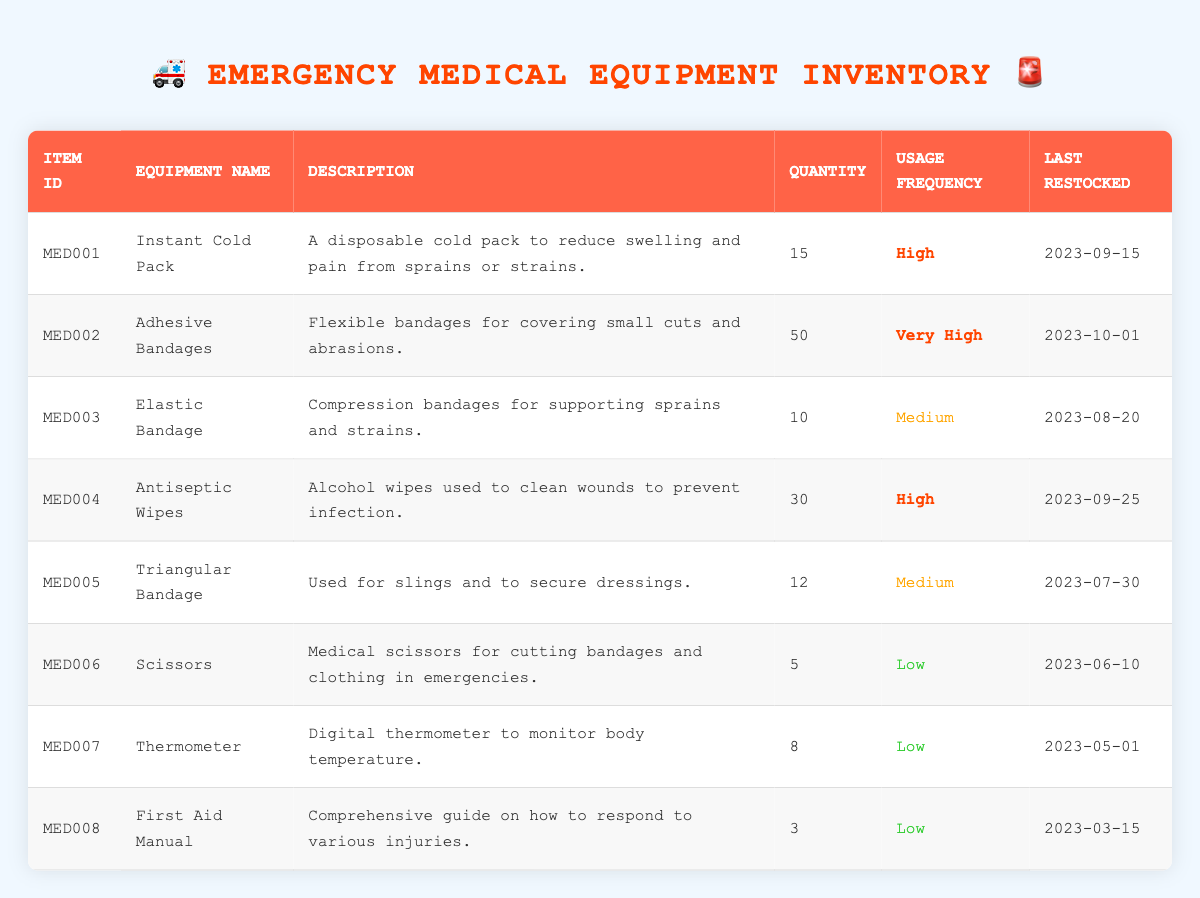What is the quantity of Adhesive Bandages in stock? The table shows the row for Adhesive Bandages, where the Quantity is listed as 50.
Answer: 50 What equipment has the highest usage frequency? By checking the Usage Frequency column, Adhesive Bandages have a frequency categorized as "Very High."
Answer: Adhesive Bandages How many more Instant Cold Packs are there than Elastic Bandages? The quantity of Instant Cold Packs is 15 and Elastic Bandages is 10. Subtracting gives us 15 - 10 = 5.
Answer: 5 Is the Thermometer's quantity greater than the quantity of Scissors? Looking at the respective quantities in the table, Thermometer has 8 and Scissors has 5. 8 is greater than 5, so the statement is true.
Answer: Yes What is the total number of items for Instant Cold Packs, Antiseptic Wipes, and Triangular Bandages? The quantities are 15 for Instant Cold Packs, 30 for Antiseptic Wipes, and 12 for Triangular Bandages. Adding them gives us 15 + 30 + 12 = 57.
Answer: 57 When was the last restocking date for equipment that is categorized as Medium usage frequency? The Medium usage frequency equipment are Elastic Bandage (2023-08-20) and Triangular Bandage (2023-07-30). The latest restocking date is 2023-08-20.
Answer: 2023-08-20 How many items in the inventory are classified under Low usage frequency? The items Scissors, Thermometer, and First Aid Manual are classified under Low usage frequency, totaling to 3 items.
Answer: 3 What is the total quantity of items in the inventory? By summing all the quantities: 15 (Instant Cold Pack) + 50 (Adhesive Bandages) + 10 (Elastic Bandage) + 30 (Antiseptic Wipes) + 12 (Triangular Bandage) + 5 (Scissors) + 8 (Thermometer) + 3 (First Aid Manual) results in 133.
Answer: 133 Does the inventory have any equipment that hasn't been restocked in the last 3 months? The First Aid Manual was last restocked on 2023-03-15, which is more than 3 months ago from today's date. Therefore, there is equipment that hasn't been restocked recently.
Answer: Yes 